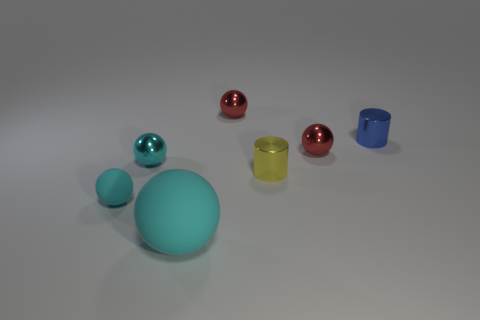Subtract all cyan balls. How many were subtracted if there are1cyan balls left? 2 Subtract all yellow cubes. How many cyan balls are left? 3 Subtract 2 balls. How many balls are left? 3 Subtract all large cyan spheres. How many spheres are left? 4 Subtract all blue spheres. Subtract all brown blocks. How many spheres are left? 5 Add 1 small objects. How many objects exist? 8 Subtract all cylinders. How many objects are left? 5 Subtract all tiny objects. Subtract all tiny cyan matte things. How many objects are left? 0 Add 6 cyan rubber objects. How many cyan rubber objects are left? 8 Add 2 small metallic spheres. How many small metallic spheres exist? 5 